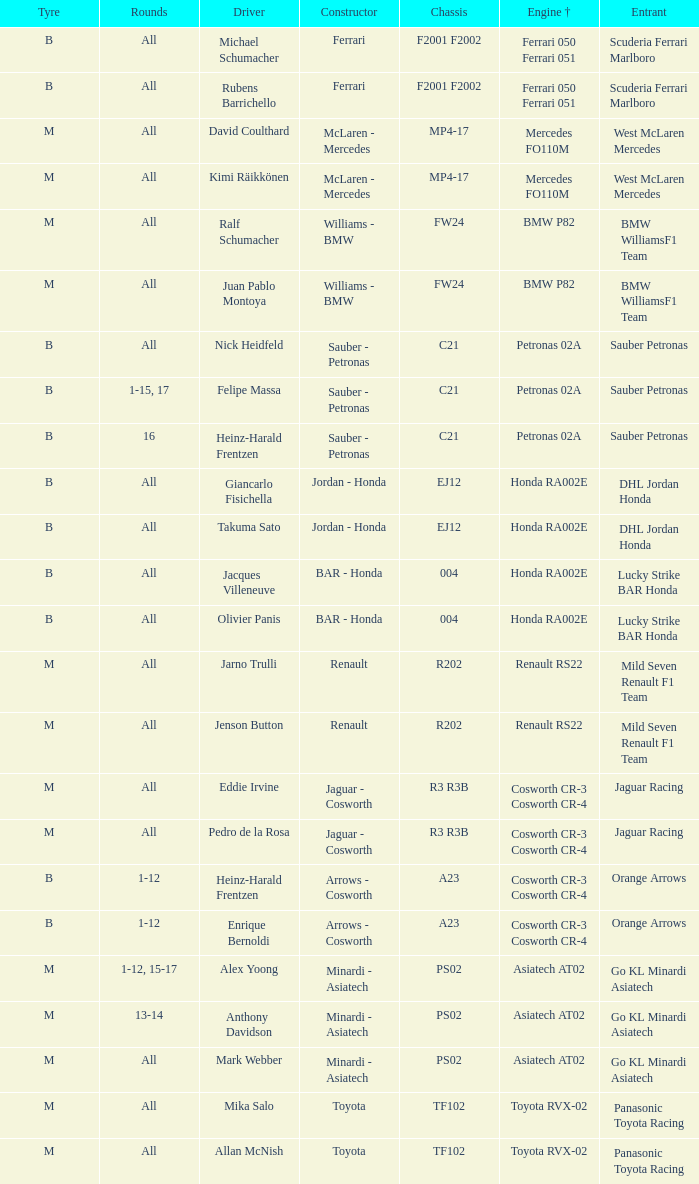What is the engine when the rounds ar all, the tyre is m and the driver is david coulthard? Mercedes FO110M. 